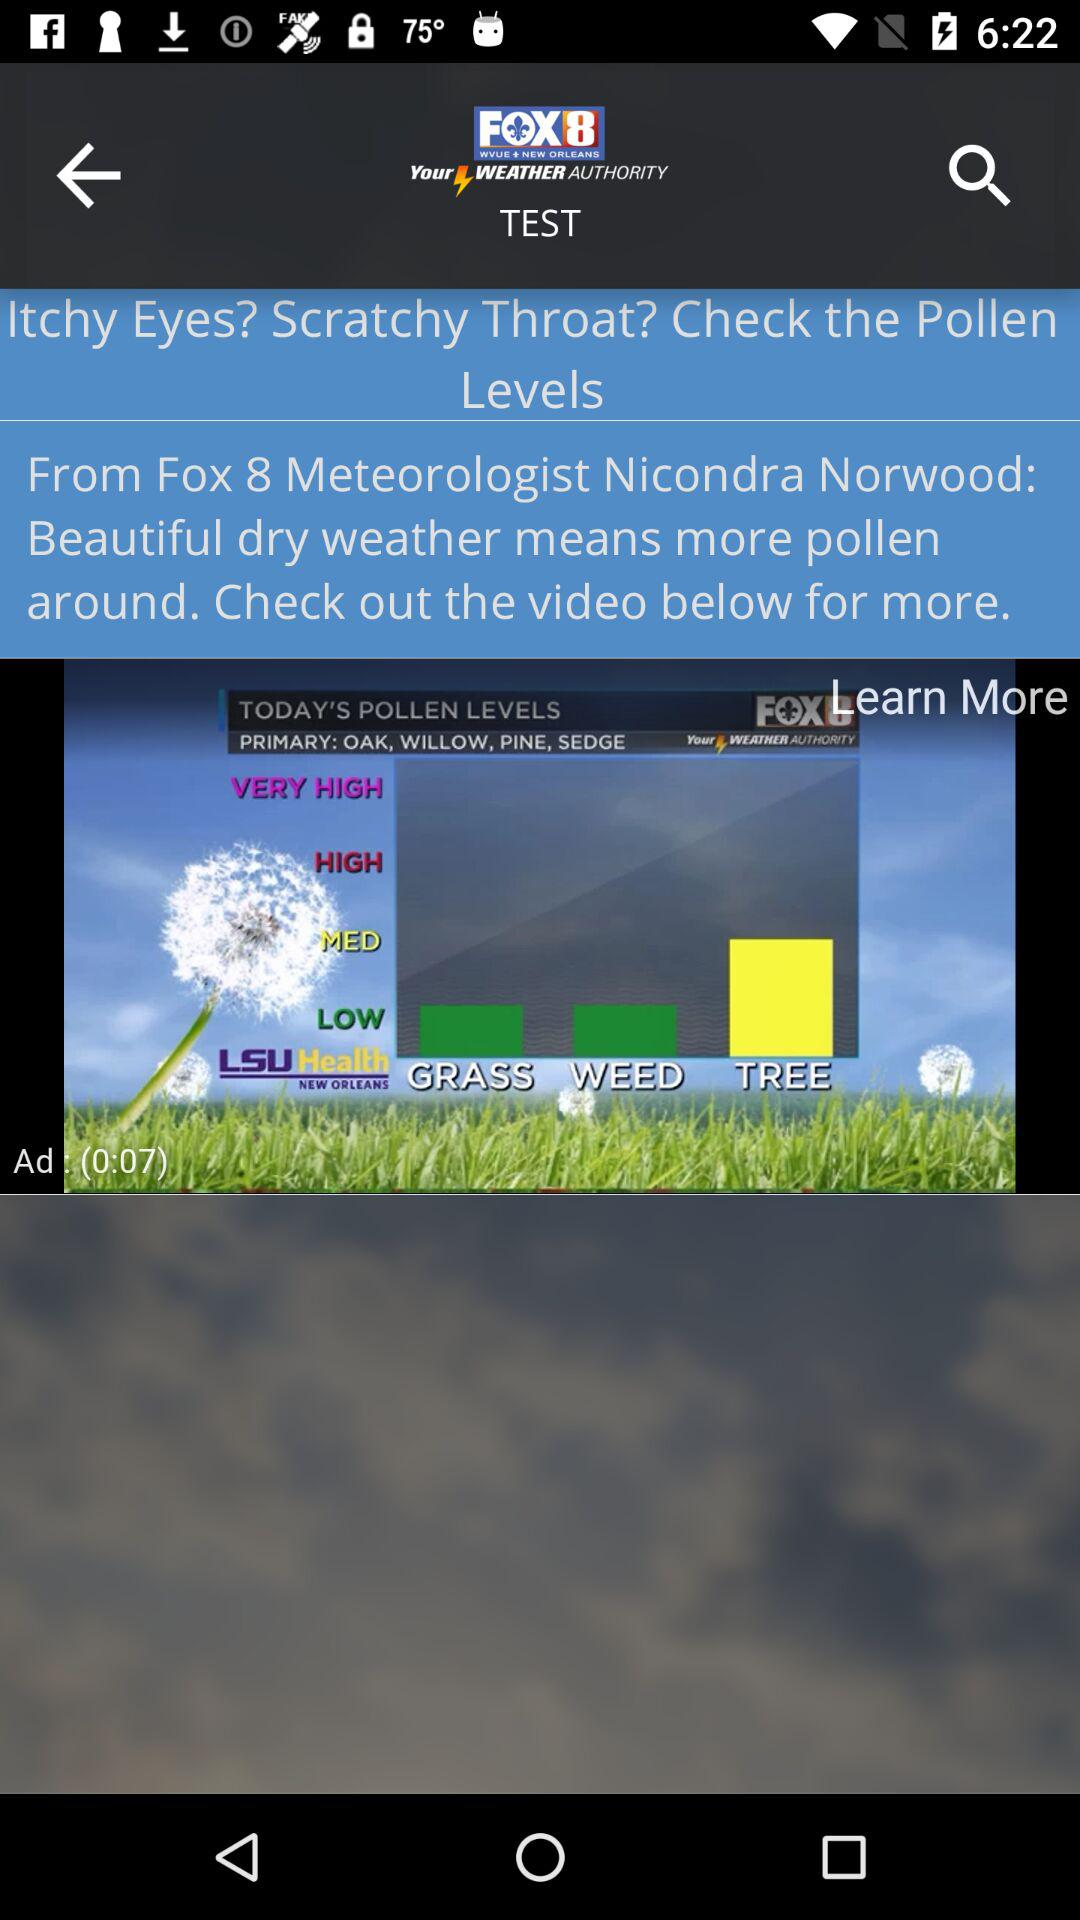How many seconds long is the video?
Answer the question using a single word or phrase. 7 